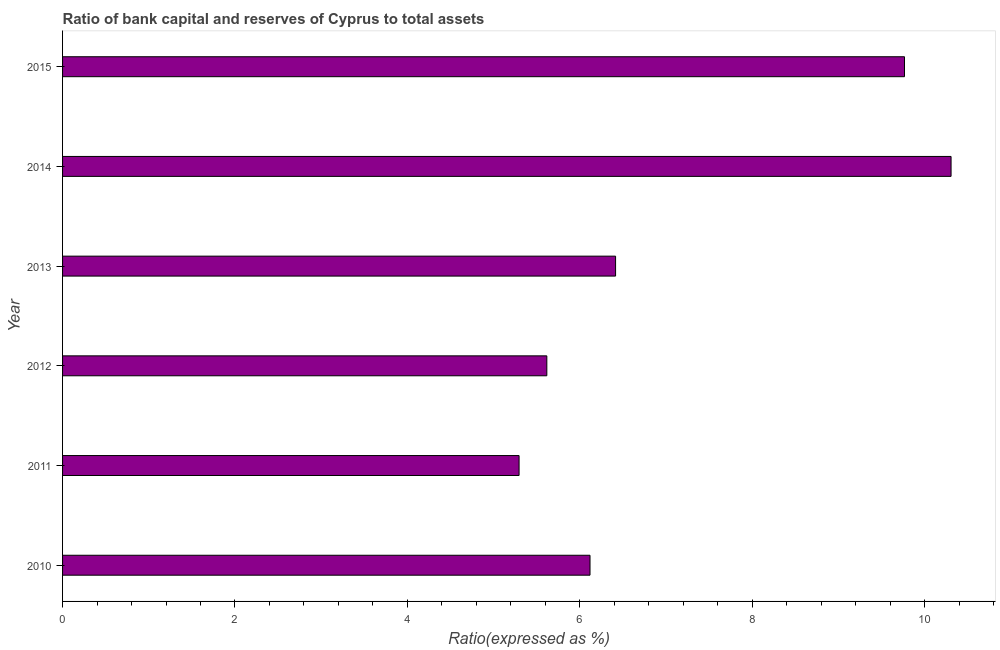What is the title of the graph?
Offer a terse response. Ratio of bank capital and reserves of Cyprus to total assets. What is the label or title of the X-axis?
Your answer should be very brief. Ratio(expressed as %). What is the bank capital to assets ratio in 2011?
Offer a very short reply. 5.3. Across all years, what is the maximum bank capital to assets ratio?
Your answer should be compact. 10.31. Across all years, what is the minimum bank capital to assets ratio?
Ensure brevity in your answer.  5.3. In which year was the bank capital to assets ratio minimum?
Offer a very short reply. 2011. What is the sum of the bank capital to assets ratio?
Provide a succinct answer. 43.52. What is the difference between the bank capital to assets ratio in 2012 and 2015?
Keep it short and to the point. -4.15. What is the average bank capital to assets ratio per year?
Your response must be concise. 7.25. What is the median bank capital to assets ratio?
Offer a terse response. 6.27. In how many years, is the bank capital to assets ratio greater than 7.6 %?
Give a very brief answer. 2. Do a majority of the years between 2014 and 2011 (inclusive) have bank capital to assets ratio greater than 5.2 %?
Your answer should be compact. Yes. What is the ratio of the bank capital to assets ratio in 2012 to that in 2014?
Your answer should be compact. 0.55. Is the difference between the bank capital to assets ratio in 2011 and 2014 greater than the difference between any two years?
Offer a terse response. Yes. What is the difference between the highest and the second highest bank capital to assets ratio?
Keep it short and to the point. 0.54. Is the sum of the bank capital to assets ratio in 2012 and 2014 greater than the maximum bank capital to assets ratio across all years?
Your response must be concise. Yes. What is the difference between the highest and the lowest bank capital to assets ratio?
Your answer should be compact. 5.01. How many bars are there?
Your response must be concise. 6. Are all the bars in the graph horizontal?
Your response must be concise. Yes. How many years are there in the graph?
Your response must be concise. 6. What is the difference between two consecutive major ticks on the X-axis?
Offer a terse response. 2. What is the Ratio(expressed as %) in 2010?
Your response must be concise. 6.12. What is the Ratio(expressed as %) of 2011?
Provide a succinct answer. 5.3. What is the Ratio(expressed as %) of 2012?
Keep it short and to the point. 5.62. What is the Ratio(expressed as %) of 2013?
Your response must be concise. 6.41. What is the Ratio(expressed as %) in 2014?
Give a very brief answer. 10.31. What is the Ratio(expressed as %) in 2015?
Your answer should be very brief. 9.77. What is the difference between the Ratio(expressed as %) in 2010 and 2011?
Your answer should be very brief. 0.82. What is the difference between the Ratio(expressed as %) in 2010 and 2012?
Give a very brief answer. 0.5. What is the difference between the Ratio(expressed as %) in 2010 and 2013?
Make the answer very short. -0.3. What is the difference between the Ratio(expressed as %) in 2010 and 2014?
Your answer should be very brief. -4.19. What is the difference between the Ratio(expressed as %) in 2010 and 2015?
Your response must be concise. -3.65. What is the difference between the Ratio(expressed as %) in 2011 and 2012?
Your answer should be compact. -0.32. What is the difference between the Ratio(expressed as %) in 2011 and 2013?
Provide a succinct answer. -1.12. What is the difference between the Ratio(expressed as %) in 2011 and 2014?
Provide a short and direct response. -5.01. What is the difference between the Ratio(expressed as %) in 2011 and 2015?
Offer a very short reply. -4.47. What is the difference between the Ratio(expressed as %) in 2012 and 2013?
Your response must be concise. -0.8. What is the difference between the Ratio(expressed as %) in 2012 and 2014?
Provide a succinct answer. -4.69. What is the difference between the Ratio(expressed as %) in 2012 and 2015?
Provide a short and direct response. -4.15. What is the difference between the Ratio(expressed as %) in 2013 and 2014?
Provide a short and direct response. -3.89. What is the difference between the Ratio(expressed as %) in 2013 and 2015?
Offer a very short reply. -3.35. What is the difference between the Ratio(expressed as %) in 2014 and 2015?
Offer a very short reply. 0.54. What is the ratio of the Ratio(expressed as %) in 2010 to that in 2011?
Offer a very short reply. 1.16. What is the ratio of the Ratio(expressed as %) in 2010 to that in 2012?
Your answer should be compact. 1.09. What is the ratio of the Ratio(expressed as %) in 2010 to that in 2013?
Make the answer very short. 0.95. What is the ratio of the Ratio(expressed as %) in 2010 to that in 2014?
Your answer should be very brief. 0.59. What is the ratio of the Ratio(expressed as %) in 2010 to that in 2015?
Provide a short and direct response. 0.63. What is the ratio of the Ratio(expressed as %) in 2011 to that in 2012?
Ensure brevity in your answer.  0.94. What is the ratio of the Ratio(expressed as %) in 2011 to that in 2013?
Your answer should be very brief. 0.82. What is the ratio of the Ratio(expressed as %) in 2011 to that in 2014?
Give a very brief answer. 0.51. What is the ratio of the Ratio(expressed as %) in 2011 to that in 2015?
Your response must be concise. 0.54. What is the ratio of the Ratio(expressed as %) in 2012 to that in 2013?
Make the answer very short. 0.88. What is the ratio of the Ratio(expressed as %) in 2012 to that in 2014?
Make the answer very short. 0.55. What is the ratio of the Ratio(expressed as %) in 2012 to that in 2015?
Make the answer very short. 0.57. What is the ratio of the Ratio(expressed as %) in 2013 to that in 2014?
Your answer should be compact. 0.62. What is the ratio of the Ratio(expressed as %) in 2013 to that in 2015?
Offer a terse response. 0.66. What is the ratio of the Ratio(expressed as %) in 2014 to that in 2015?
Provide a succinct answer. 1.05. 